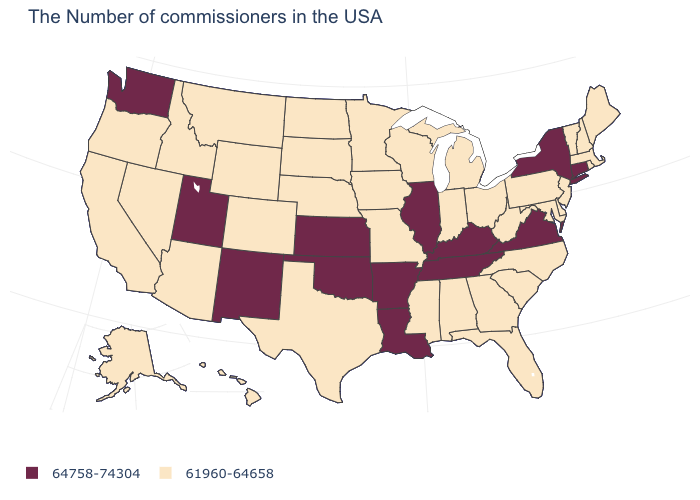Does the map have missing data?
Be succinct. No. What is the value of Massachusetts?
Quick response, please. 61960-64658. What is the value of Rhode Island?
Keep it brief. 61960-64658. What is the value of New Hampshire?
Concise answer only. 61960-64658. What is the lowest value in the MidWest?
Quick response, please. 61960-64658. Name the states that have a value in the range 61960-64658?
Write a very short answer. Maine, Massachusetts, Rhode Island, New Hampshire, Vermont, New Jersey, Delaware, Maryland, Pennsylvania, North Carolina, South Carolina, West Virginia, Ohio, Florida, Georgia, Michigan, Indiana, Alabama, Wisconsin, Mississippi, Missouri, Minnesota, Iowa, Nebraska, Texas, South Dakota, North Dakota, Wyoming, Colorado, Montana, Arizona, Idaho, Nevada, California, Oregon, Alaska, Hawaii. What is the highest value in states that border Maine?
Write a very short answer. 61960-64658. Among the states that border Vermont , which have the highest value?
Write a very short answer. New York. What is the lowest value in the MidWest?
Answer briefly. 61960-64658. What is the highest value in the USA?
Give a very brief answer. 64758-74304. Does Delaware have a lower value than Oregon?
Be succinct. No. What is the highest value in the West ?
Be succinct. 64758-74304. Does Wisconsin have the same value as New Mexico?
Write a very short answer. No. Name the states that have a value in the range 64758-74304?
Be succinct. Connecticut, New York, Virginia, Kentucky, Tennessee, Illinois, Louisiana, Arkansas, Kansas, Oklahoma, New Mexico, Utah, Washington. What is the value of Arizona?
Concise answer only. 61960-64658. 